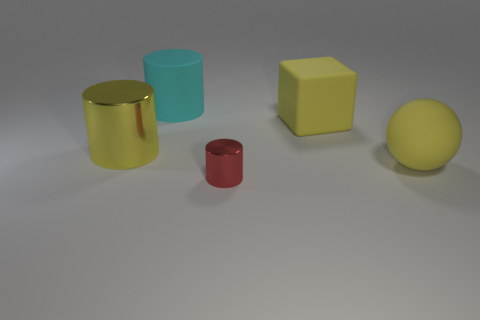What number of cubes are there?
Your answer should be compact. 1. How many small objects are either rubber blocks or red things?
Your response must be concise. 1. What shape is the cyan object that is the same size as the yellow rubber cube?
Keep it short and to the point. Cylinder. Is there any other thing that is the same size as the yellow matte sphere?
Provide a short and direct response. Yes. There is a large yellow object that is to the left of the rubber thing that is on the left side of the rubber block; what is its material?
Provide a short and direct response. Metal. Is the rubber ball the same size as the matte cylinder?
Your response must be concise. Yes. How many objects are either big yellow objects on the right side of the block or big gray metallic objects?
Offer a very short reply. 1. What is the shape of the big yellow object that is behind the shiny object on the left side of the small red object?
Offer a very short reply. Cube. Do the yellow shiny cylinder and the matte object to the left of the tiny red thing have the same size?
Your response must be concise. Yes. What material is the large object in front of the big metal object?
Offer a terse response. Rubber. 